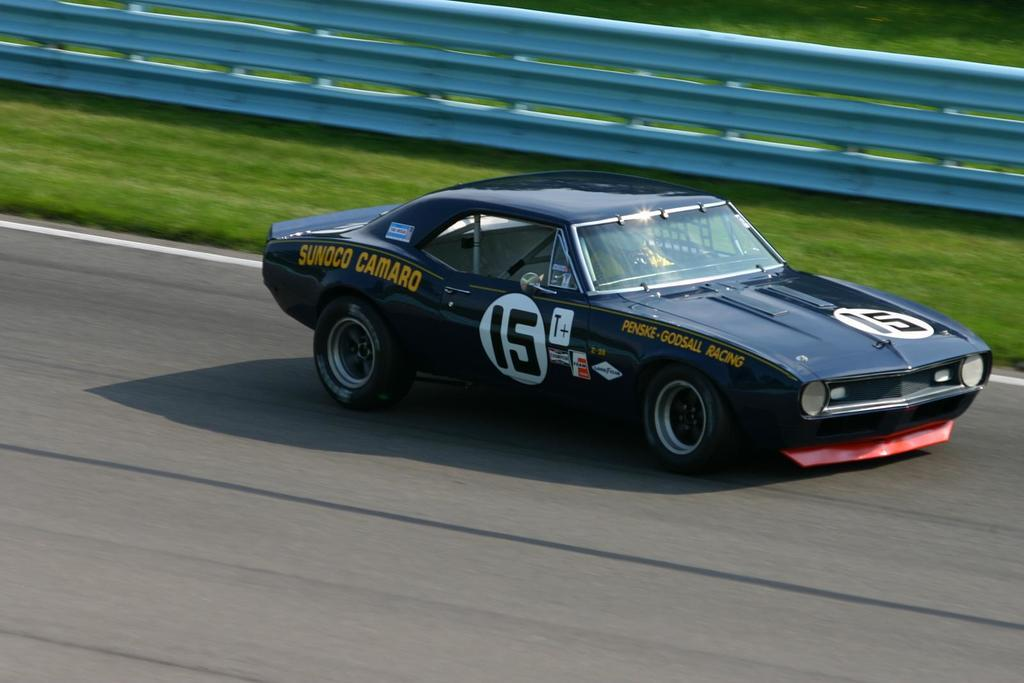What is on the road in the image? There is a car on the road in the image. What type of vegetation can be seen in the image? There is grass visible in the image. What is separating the grass from the road in the image? There is a fence in the image. How many apples are hanging from the fence in the image? There are no apples present in the image; it only features a car on the road, grass, and a fence. 